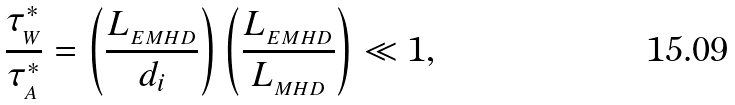<formula> <loc_0><loc_0><loc_500><loc_500>\frac { \tau _ { _ { W } } ^ { * } } { \tau _ { _ { A } } ^ { * } } = \left ( \frac { L _ { _ { E M H D } } } { d _ { i } } \right ) \left ( \frac { L _ { _ { E M H D } } } { L _ { _ { M H D } } } \right ) \ll 1 ,</formula> 